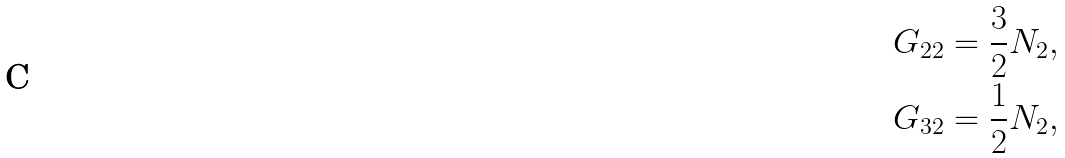Convert formula to latex. <formula><loc_0><loc_0><loc_500><loc_500>G _ { 2 2 } & = \frac { 3 } { 2 } N _ { 2 } , \\ G _ { 3 2 } & = \frac { 1 } { 2 } N _ { 2 } ,</formula> 